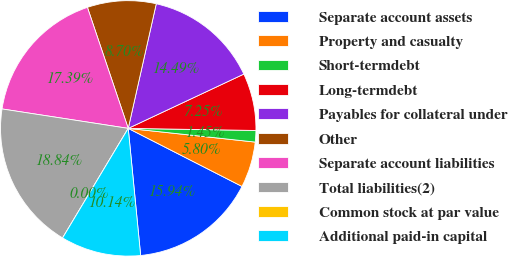Convert chart. <chart><loc_0><loc_0><loc_500><loc_500><pie_chart><fcel>Separate account assets<fcel>Property and casualty<fcel>Short-termdebt<fcel>Long-termdebt<fcel>Payables for collateral under<fcel>Other<fcel>Separate account liabilities<fcel>Total liabilities(2)<fcel>Common stock at par value<fcel>Additional paid-in capital<nl><fcel>15.94%<fcel>5.8%<fcel>1.45%<fcel>7.25%<fcel>14.49%<fcel>8.7%<fcel>17.39%<fcel>18.84%<fcel>0.0%<fcel>10.14%<nl></chart> 